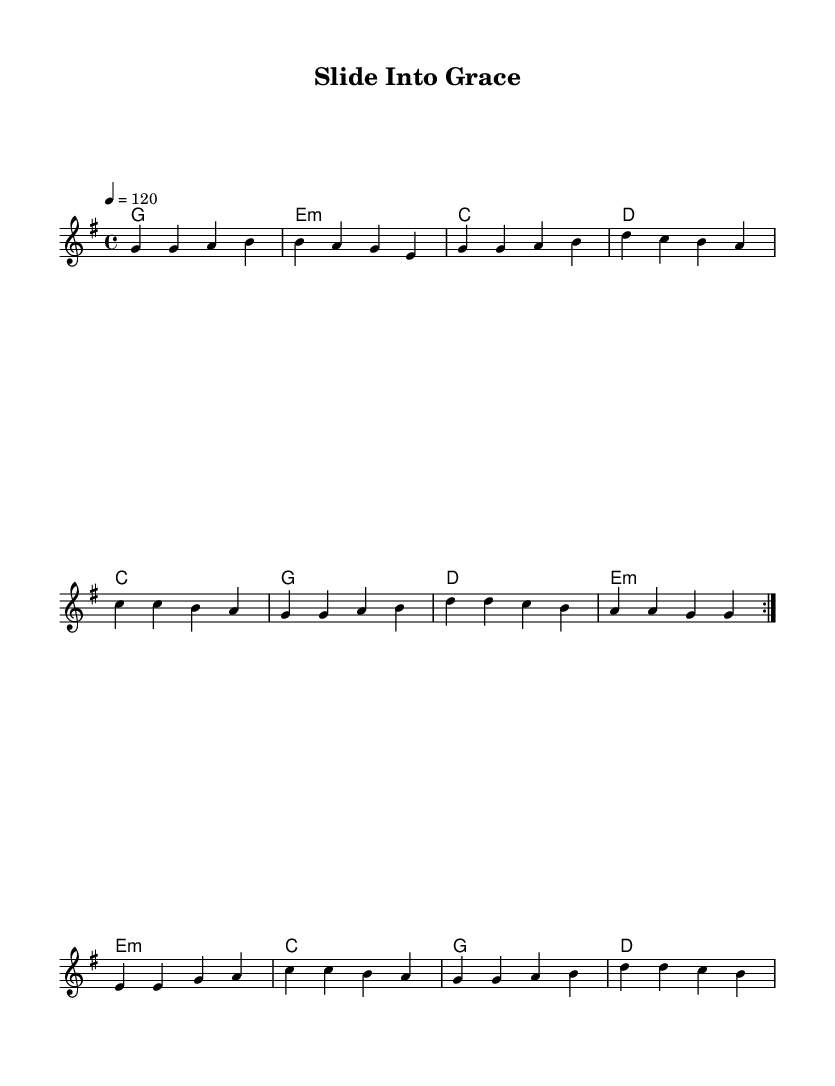What is the key signature of this music? The key signature is G major, which has one sharp (F#). This can be found at the beginning of the music sheet before the first note.
Answer: G major What is the time signature of this music? The time signature is 4/4, indicating that there are four beats in each measure and a quarter note gets one beat. This is positioned at the start of the music, informing us how to count the rhythm.
Answer: 4/4 What is the tempo marking of this music? The tempo marking is 120 beats per minute, indicated by the notation that specifies the beats per minute. This guides the performers on how fast to play the piece.
Answer: 120 How many measures are in the verse section? The verse contains eight measures as counted from the lyrics section, which aligns with the musical phrases shown in the melody. Each line represents a measure based on the notation.
Answer: Eight What does “slide into grace” symbolize in relation to the song's theme? "Slide into grace" symbolizes receiving God's acceptance and forgiveness, aligning with the metaphor of sliding safely into home plate in baseball. This thematic imagery constructs a positive message about faith and redemption.
Answer: Acceptance What musical device is used in the bridge of this song? The bridge employs a contrasting structure, shifting dynamics and lyrical focus, creating a change from the verse. This reinforces connection through different musical phrases to build tension and lead back to the anthem feel.
Answer: Contrast 